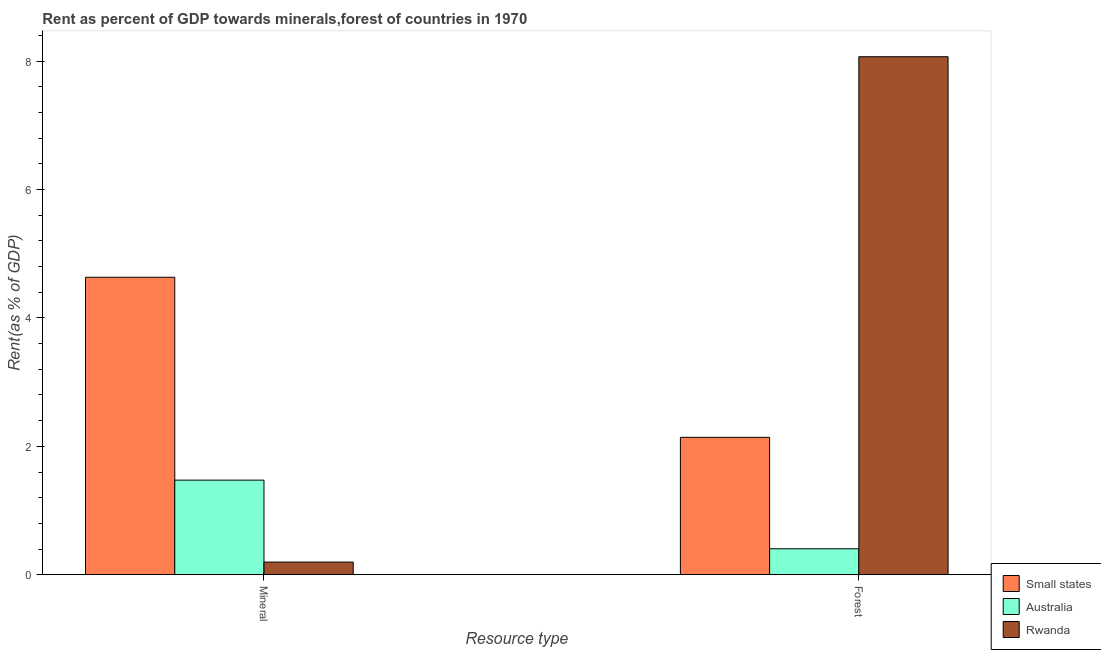Are the number of bars on each tick of the X-axis equal?
Offer a very short reply. Yes. How many bars are there on the 1st tick from the left?
Provide a short and direct response. 3. What is the label of the 2nd group of bars from the left?
Provide a succinct answer. Forest. What is the forest rent in Rwanda?
Offer a very short reply. 8.07. Across all countries, what is the maximum forest rent?
Offer a terse response. 8.07. Across all countries, what is the minimum mineral rent?
Offer a terse response. 0.2. In which country was the forest rent maximum?
Your answer should be very brief. Rwanda. What is the total forest rent in the graph?
Your answer should be very brief. 10.62. What is the difference between the forest rent in Rwanda and that in Small states?
Your response must be concise. 5.93. What is the difference between the forest rent in Small states and the mineral rent in Rwanda?
Give a very brief answer. 1.94. What is the average mineral rent per country?
Make the answer very short. 2.1. What is the difference between the mineral rent and forest rent in Rwanda?
Ensure brevity in your answer.  -7.87. What is the ratio of the forest rent in Rwanda to that in Australia?
Ensure brevity in your answer.  19.98. What does the 1st bar from the right in Forest represents?
Provide a short and direct response. Rwanda. Are all the bars in the graph horizontal?
Your answer should be very brief. No. How many countries are there in the graph?
Offer a very short reply. 3. What is the difference between two consecutive major ticks on the Y-axis?
Offer a terse response. 2. Are the values on the major ticks of Y-axis written in scientific E-notation?
Give a very brief answer. No. Does the graph contain grids?
Your answer should be very brief. No. What is the title of the graph?
Your answer should be compact. Rent as percent of GDP towards minerals,forest of countries in 1970. What is the label or title of the X-axis?
Offer a very short reply. Resource type. What is the label or title of the Y-axis?
Give a very brief answer. Rent(as % of GDP). What is the Rent(as % of GDP) of Small states in Mineral?
Your response must be concise. 4.63. What is the Rent(as % of GDP) of Australia in Mineral?
Your answer should be very brief. 1.47. What is the Rent(as % of GDP) of Rwanda in Mineral?
Provide a short and direct response. 0.2. What is the Rent(as % of GDP) of Small states in Forest?
Give a very brief answer. 2.14. What is the Rent(as % of GDP) of Australia in Forest?
Your answer should be compact. 0.4. What is the Rent(as % of GDP) of Rwanda in Forest?
Offer a terse response. 8.07. Across all Resource type, what is the maximum Rent(as % of GDP) of Small states?
Provide a succinct answer. 4.63. Across all Resource type, what is the maximum Rent(as % of GDP) in Australia?
Provide a succinct answer. 1.47. Across all Resource type, what is the maximum Rent(as % of GDP) of Rwanda?
Offer a terse response. 8.07. Across all Resource type, what is the minimum Rent(as % of GDP) of Small states?
Your answer should be compact. 2.14. Across all Resource type, what is the minimum Rent(as % of GDP) in Australia?
Ensure brevity in your answer.  0.4. Across all Resource type, what is the minimum Rent(as % of GDP) in Rwanda?
Provide a short and direct response. 0.2. What is the total Rent(as % of GDP) in Small states in the graph?
Your answer should be very brief. 6.78. What is the total Rent(as % of GDP) in Australia in the graph?
Your response must be concise. 1.88. What is the total Rent(as % of GDP) of Rwanda in the graph?
Provide a short and direct response. 8.27. What is the difference between the Rent(as % of GDP) in Small states in Mineral and that in Forest?
Make the answer very short. 2.49. What is the difference between the Rent(as % of GDP) in Australia in Mineral and that in Forest?
Your answer should be very brief. 1.07. What is the difference between the Rent(as % of GDP) in Rwanda in Mineral and that in Forest?
Give a very brief answer. -7.87. What is the difference between the Rent(as % of GDP) of Small states in Mineral and the Rent(as % of GDP) of Australia in Forest?
Offer a terse response. 4.23. What is the difference between the Rent(as % of GDP) of Small states in Mineral and the Rent(as % of GDP) of Rwanda in Forest?
Ensure brevity in your answer.  -3.44. What is the difference between the Rent(as % of GDP) in Australia in Mineral and the Rent(as % of GDP) in Rwanda in Forest?
Keep it short and to the point. -6.6. What is the average Rent(as % of GDP) of Small states per Resource type?
Your response must be concise. 3.39. What is the average Rent(as % of GDP) in Australia per Resource type?
Offer a very short reply. 0.94. What is the average Rent(as % of GDP) in Rwanda per Resource type?
Your response must be concise. 4.13. What is the difference between the Rent(as % of GDP) of Small states and Rent(as % of GDP) of Australia in Mineral?
Offer a terse response. 3.16. What is the difference between the Rent(as % of GDP) of Small states and Rent(as % of GDP) of Rwanda in Mineral?
Give a very brief answer. 4.44. What is the difference between the Rent(as % of GDP) of Australia and Rent(as % of GDP) of Rwanda in Mineral?
Keep it short and to the point. 1.28. What is the difference between the Rent(as % of GDP) in Small states and Rent(as % of GDP) in Australia in Forest?
Offer a terse response. 1.74. What is the difference between the Rent(as % of GDP) in Small states and Rent(as % of GDP) in Rwanda in Forest?
Ensure brevity in your answer.  -5.93. What is the difference between the Rent(as % of GDP) in Australia and Rent(as % of GDP) in Rwanda in Forest?
Ensure brevity in your answer.  -7.67. What is the ratio of the Rent(as % of GDP) in Small states in Mineral to that in Forest?
Give a very brief answer. 2.17. What is the ratio of the Rent(as % of GDP) in Australia in Mineral to that in Forest?
Your response must be concise. 3.65. What is the ratio of the Rent(as % of GDP) in Rwanda in Mineral to that in Forest?
Your answer should be compact. 0.02. What is the difference between the highest and the second highest Rent(as % of GDP) in Small states?
Keep it short and to the point. 2.49. What is the difference between the highest and the second highest Rent(as % of GDP) of Australia?
Provide a succinct answer. 1.07. What is the difference between the highest and the second highest Rent(as % of GDP) in Rwanda?
Your response must be concise. 7.87. What is the difference between the highest and the lowest Rent(as % of GDP) in Small states?
Keep it short and to the point. 2.49. What is the difference between the highest and the lowest Rent(as % of GDP) in Australia?
Offer a very short reply. 1.07. What is the difference between the highest and the lowest Rent(as % of GDP) of Rwanda?
Provide a succinct answer. 7.87. 